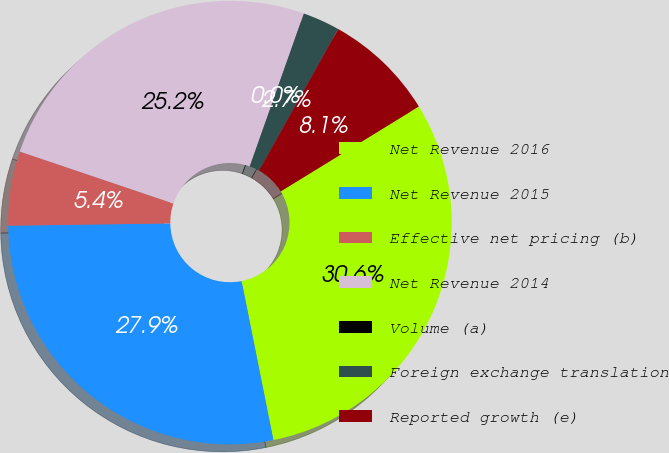Convert chart to OTSL. <chart><loc_0><loc_0><loc_500><loc_500><pie_chart><fcel>Net Revenue 2016<fcel>Net Revenue 2015<fcel>Effective net pricing (b)<fcel>Net Revenue 2014<fcel>Volume (a)<fcel>Foreign exchange translation<fcel>Reported growth (e)<nl><fcel>30.63%<fcel>27.92%<fcel>5.41%<fcel>25.22%<fcel>0.0%<fcel>2.71%<fcel>8.11%<nl></chart> 